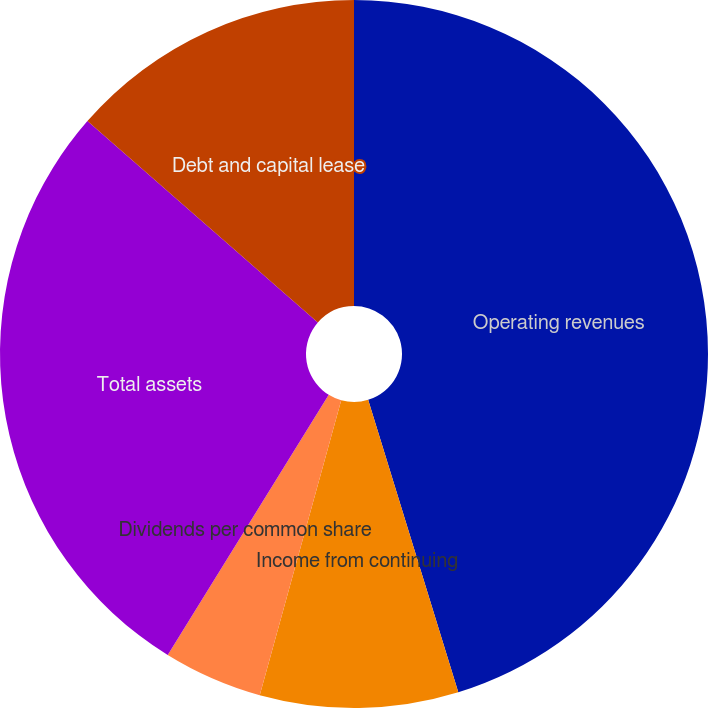<chart> <loc_0><loc_0><loc_500><loc_500><pie_chart><fcel>Operating revenues<fcel>Income from continuing<fcel>Earnings per common share from<fcel>Dividends per common share<fcel>Total assets<fcel>Debt and capital lease<nl><fcel>45.24%<fcel>9.05%<fcel>4.53%<fcel>0.0%<fcel>27.61%<fcel>13.57%<nl></chart> 